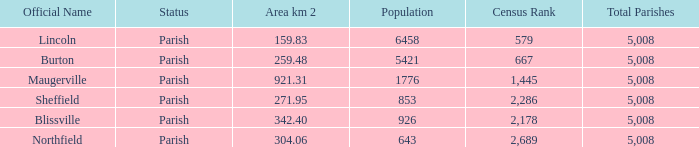What are the census ranking(s) of maugerville? 1,445 of 5,008. 